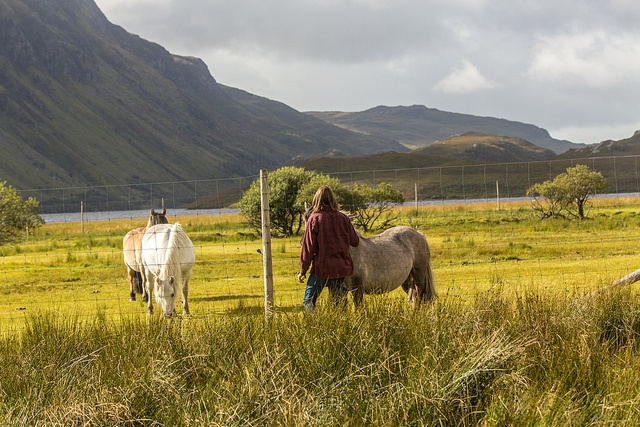Describe the objects in this image and their specific colors. I can see horse in gray and black tones, people in gray, black, maroon, olive, and brown tones, horse in gray, ivory, and tan tones, horse in gray, tan, ivory, and olive tones, and horse in gray, tan, beige, and black tones in this image. 